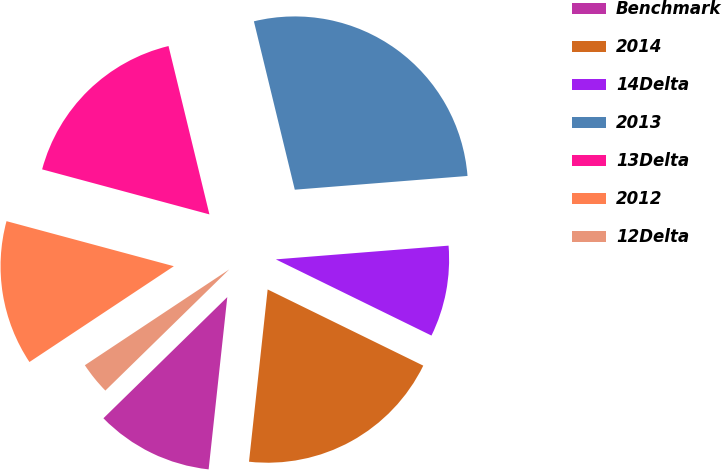<chart> <loc_0><loc_0><loc_500><loc_500><pie_chart><fcel>Benchmark<fcel>2014<fcel>14Delta<fcel>2013<fcel>13Delta<fcel>2012<fcel>12Delta<nl><fcel>10.96%<fcel>19.47%<fcel>8.51%<fcel>27.53%<fcel>17.02%<fcel>13.51%<fcel>3.0%<nl></chart> 